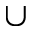Convert formula to latex. <formula><loc_0><loc_0><loc_500><loc_500>\cup</formula> 